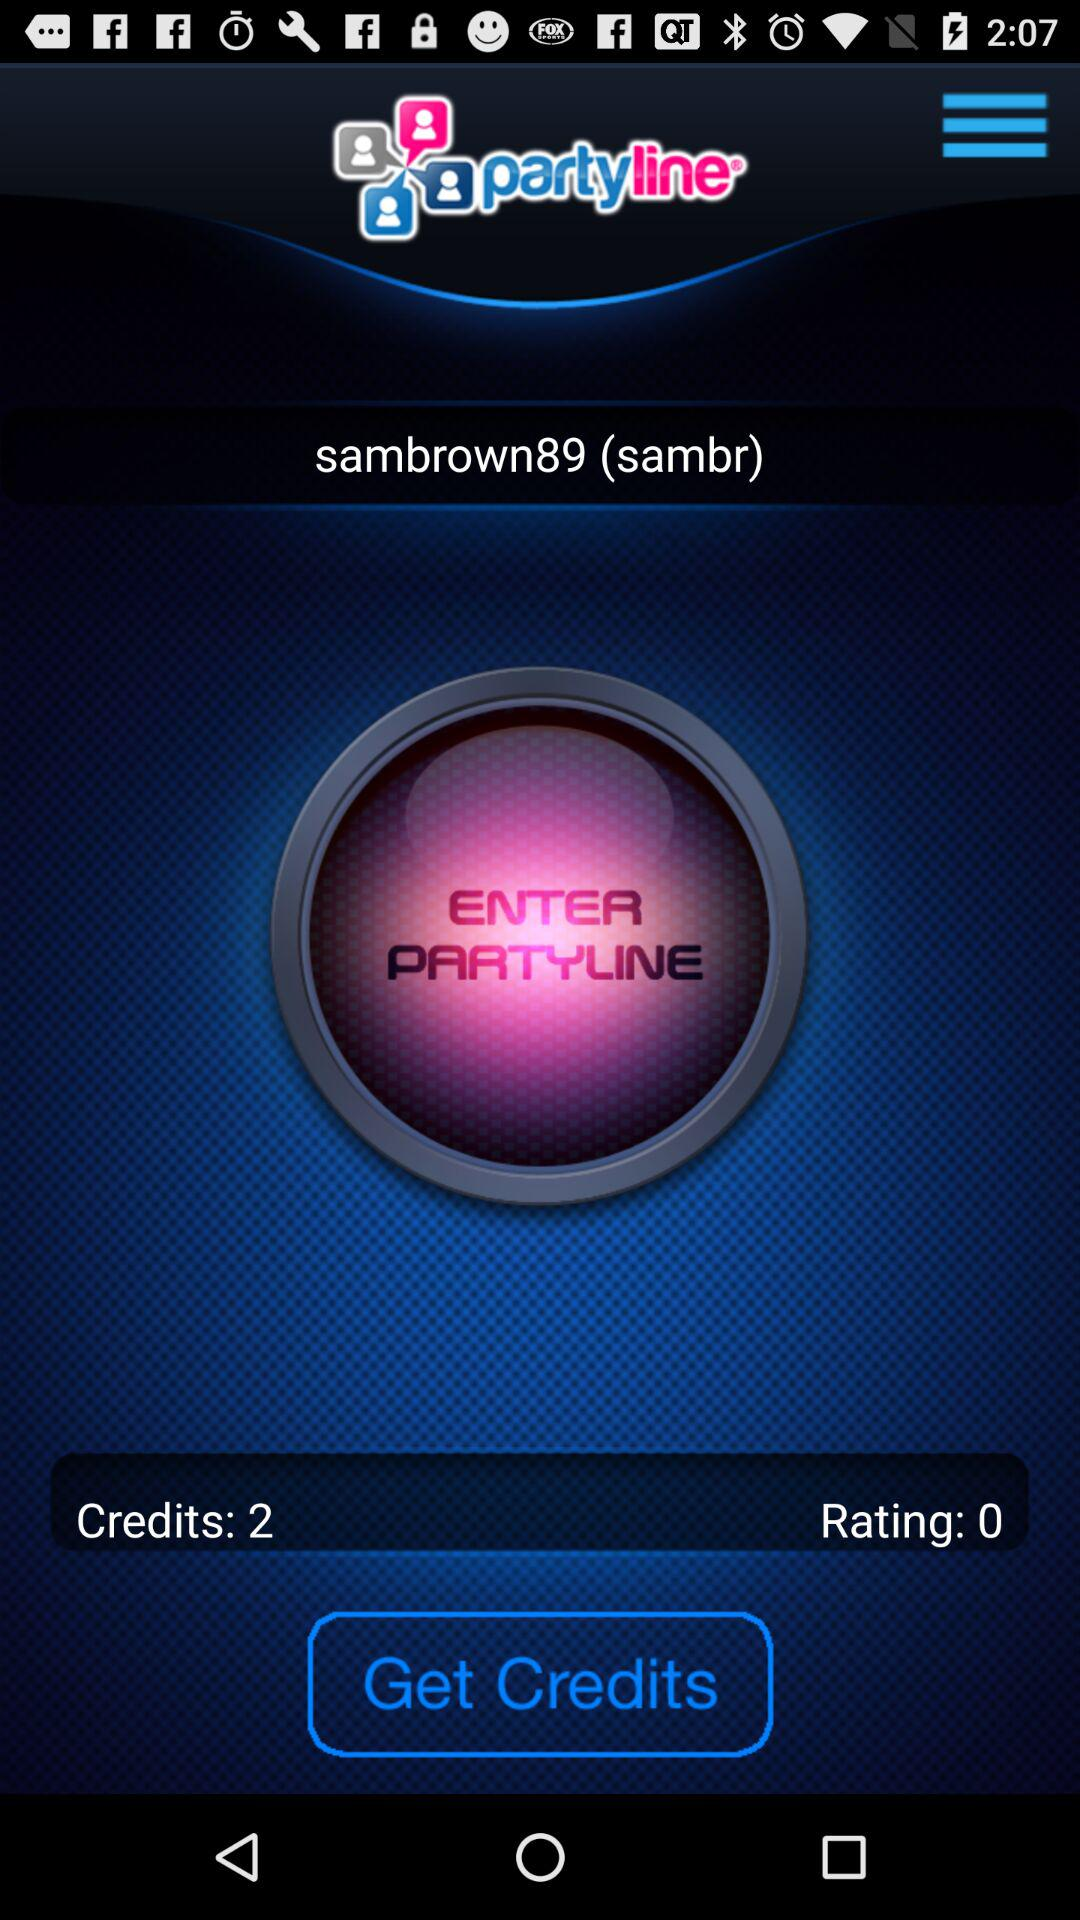What is the rating shown on the screen? The rating shown on the screen is 0. 